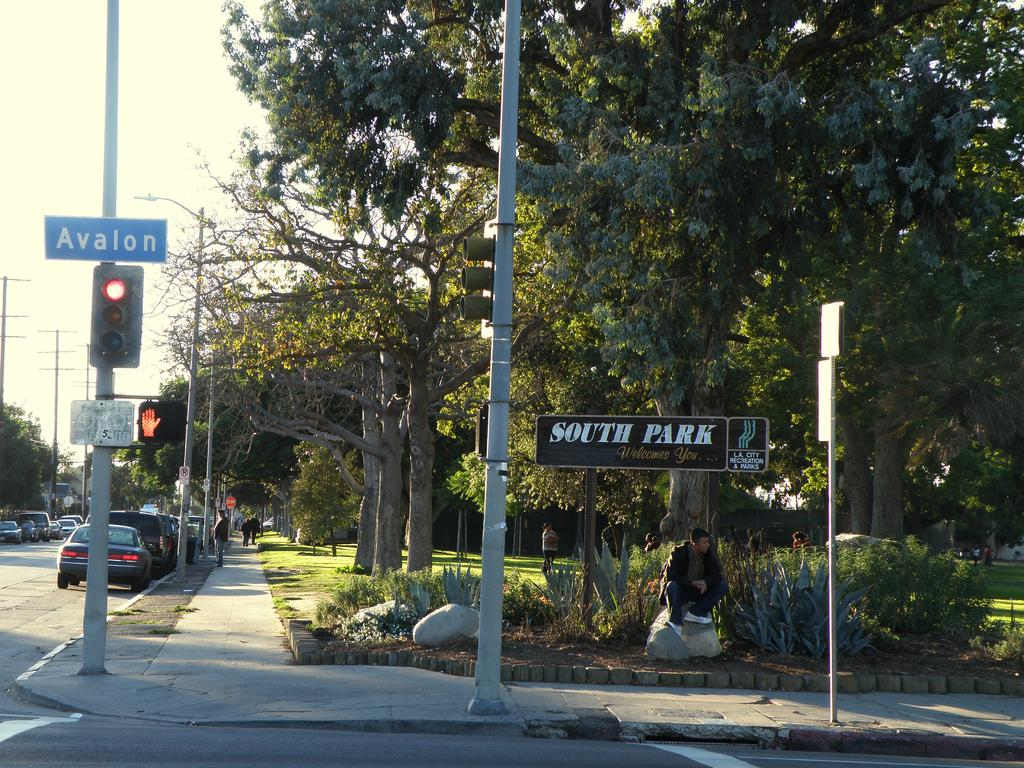<image>
Give a short and clear explanation of the subsequent image. Late afternoon sunlight shines on a street corner, where someone sits on a stone in South Park. 